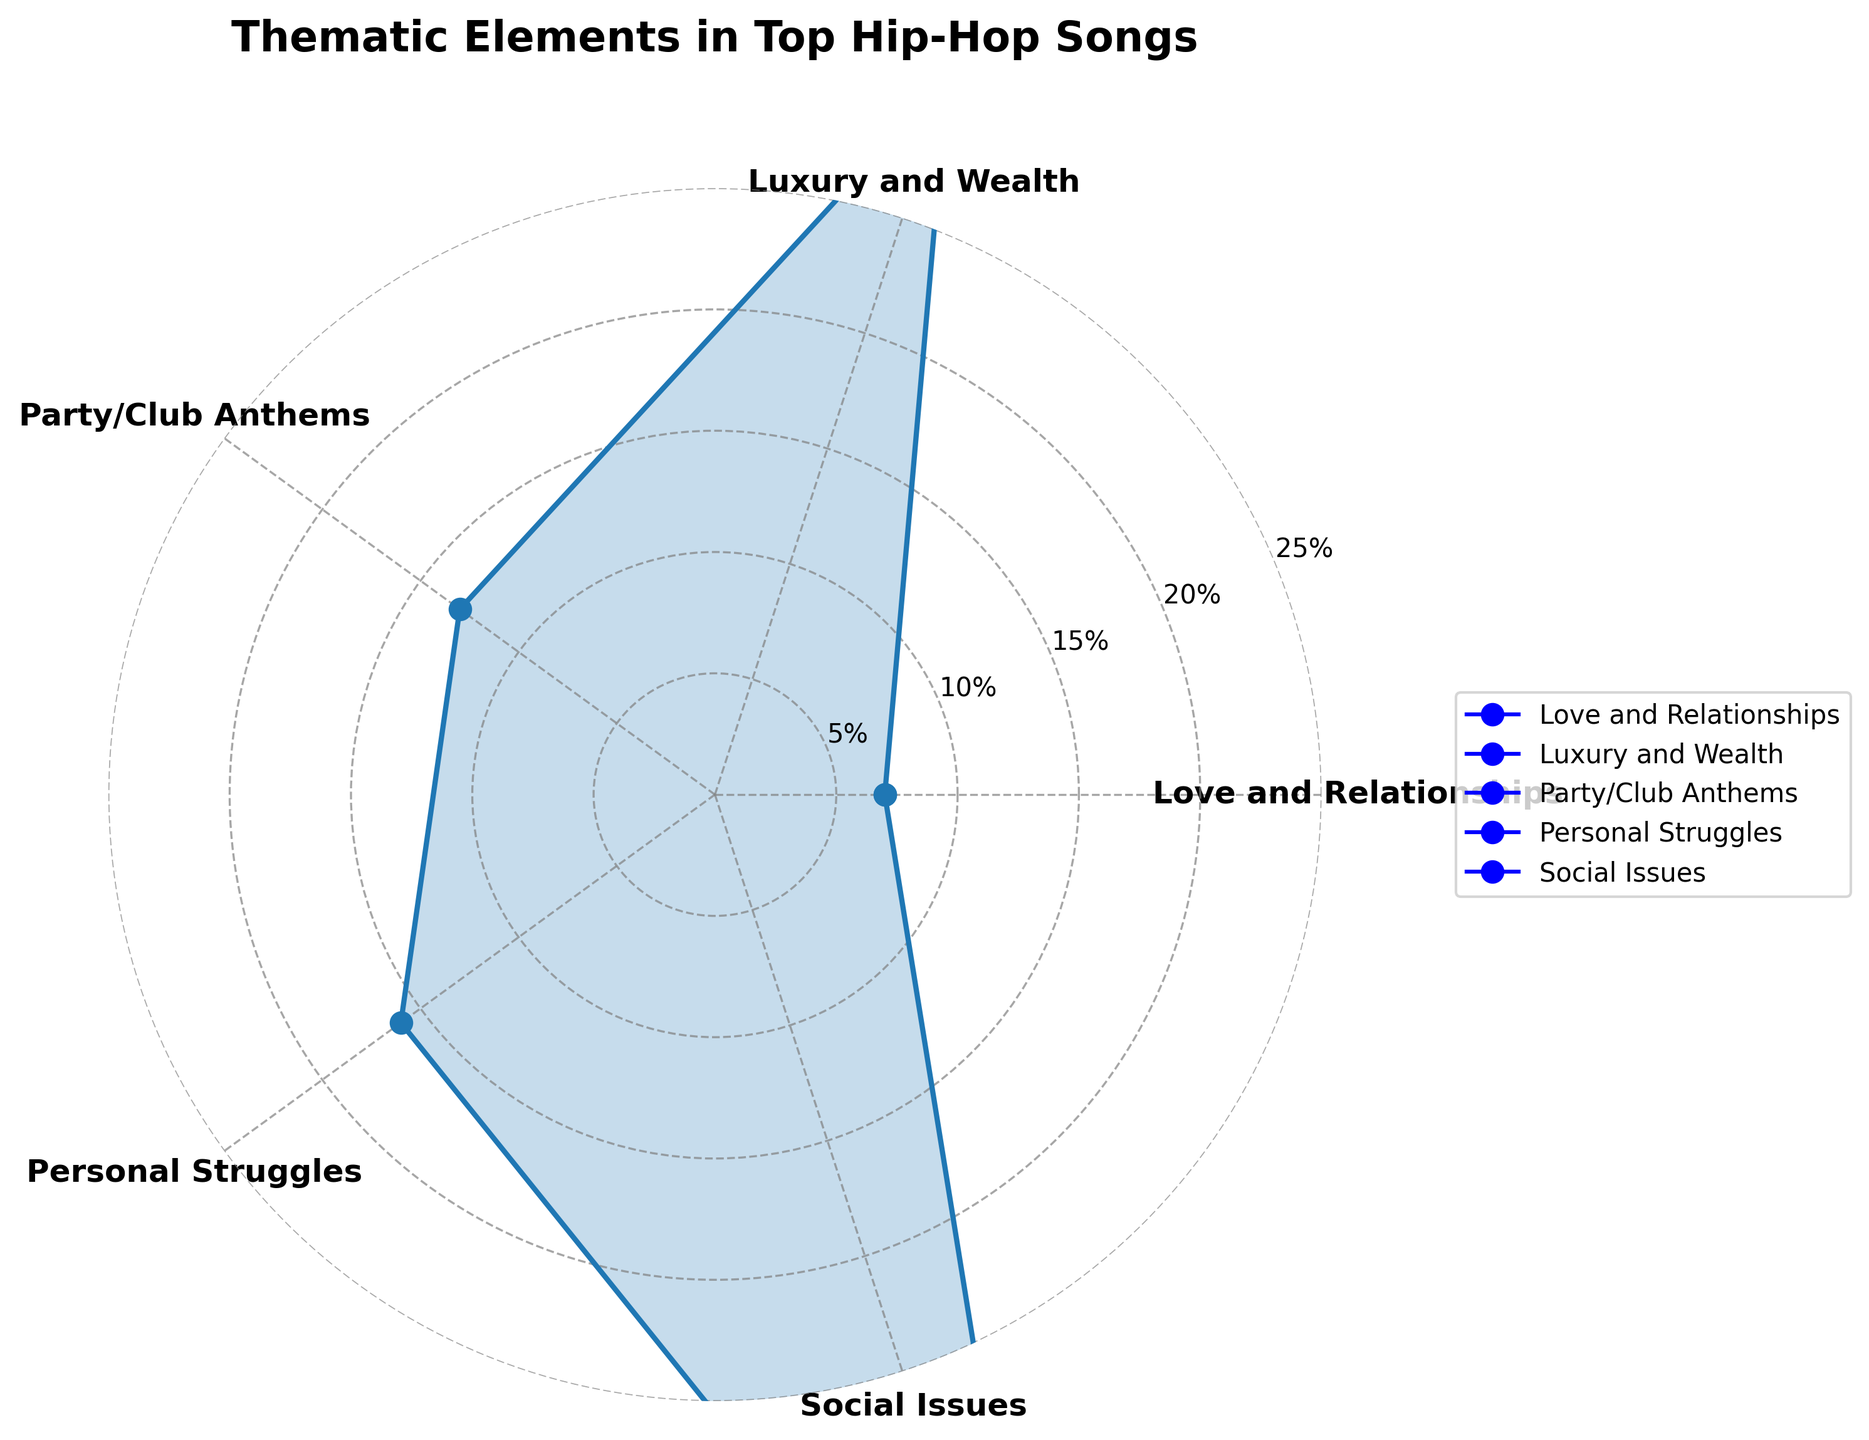What's the main thematic element in top hip-hop songs of the decade? By examining the polar area chart, the largest area represents "Social Issues" with a total percentage higher than any other category.
Answer: Social Issues Which thematic element comes after 'Social Issues' in representation? From the polar area chart, 'Luxury and Wealth' has the next largest area after 'Social Issues,' indicating it’s the second most represented thematic element.
Answer: Luxury and Wealth What is the combined percentage of themes related to social issues? There are three songs listed under 'Social Issues': 'Alright' (15%), 'This Is America' (20%), and 'The Bigger Picture' (10%). Adding these percentages gives: 15% + 20% + 10% = 45%.
Answer: 45% Which artist appears the most across different thematic elements in the chart? Kendrick Lamar appears in 'Social Issues' with 'Alright,' in 'Luxury and Wealth' with 'HUMBLE.,' and in 'Love and Relationships' with 'Love.,' making him the most frequently appearing artist.
Answer: Kendrick Lamar How does the representation of 'Party/Club Anthems' compare to 'Love and Relationships'? 'Party/Club Anthems' has a total percentage of 13% (Sicko Mode - 7%, Uptown Funk - 4%, Swag Surfin' - 2%), while 'Love and Relationships' has a total percentage of 7% (Love. - 4%, Adore You - 3%). Thus, 'Party/Club Anthems' is more represented.
Answer: Party/Club Anthems is more represented Which thematic category has the smallest representation? In the polar area chart, 'Love and Relationships' has the smallest total percentage of 7%, indicating it's the least represented.
Answer: Love and Relationships Is the proportion of 'Personal Struggles' greater than that of 'Party/Club Anthems'? 'Personal Struggles' totals 16% (Lucid Dreams - 10%, Dark Fantasy - 6%), while 'Party/Club Anthems' totals 13% (Sicko Mode - 7%, Uptown Funk - 4%, Swag Surfin' - 2%), thus 'Personal Struggles' is greater.
Answer: Yes How much larger is the 'Social Issues' category compared to the 'Love and Relationships' category? The 'Social Issues' category totals 45%, and 'Love and Relationships' totals 7%. The difference is 45% - 7% = 38%.
Answer: 38% Which thematic category includes a song outside of the hip-hop genre, and which song is it? 'Love and Relationships' includes 'Adore You' by Harry Styles, who is not typically categorized as a hip-hop artist.
Answer: 'Love and Relationships', "Adore You" by Harry Styles 